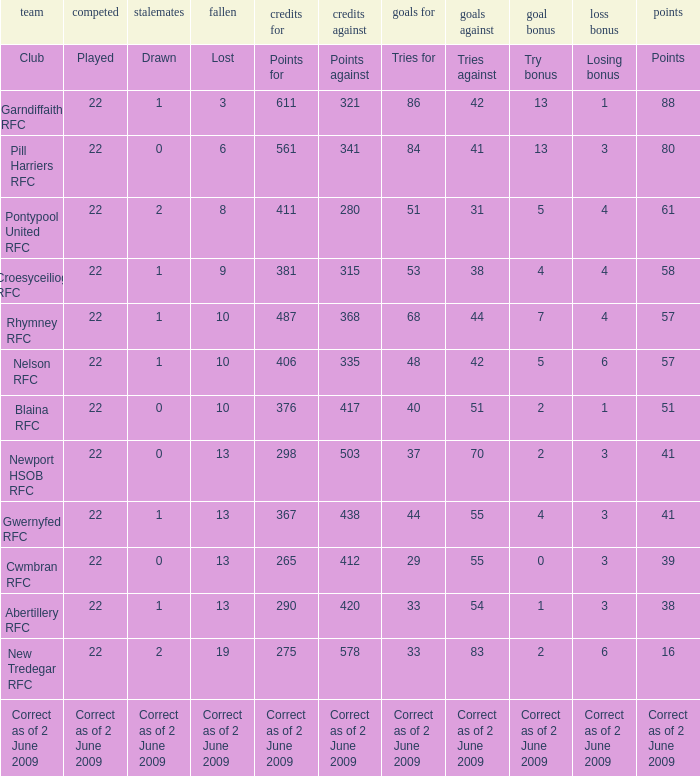How many tries did the club with a try bonus of correct as of 2 June 2009 have? Correct as of 2 June 2009. 